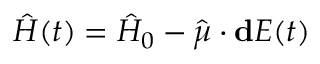Convert formula to latex. <formula><loc_0><loc_0><loc_500><loc_500>\hat { H } ( t ) = \hat { H } _ { 0 } - \hat { \mu } \cdot d E ( t )</formula> 